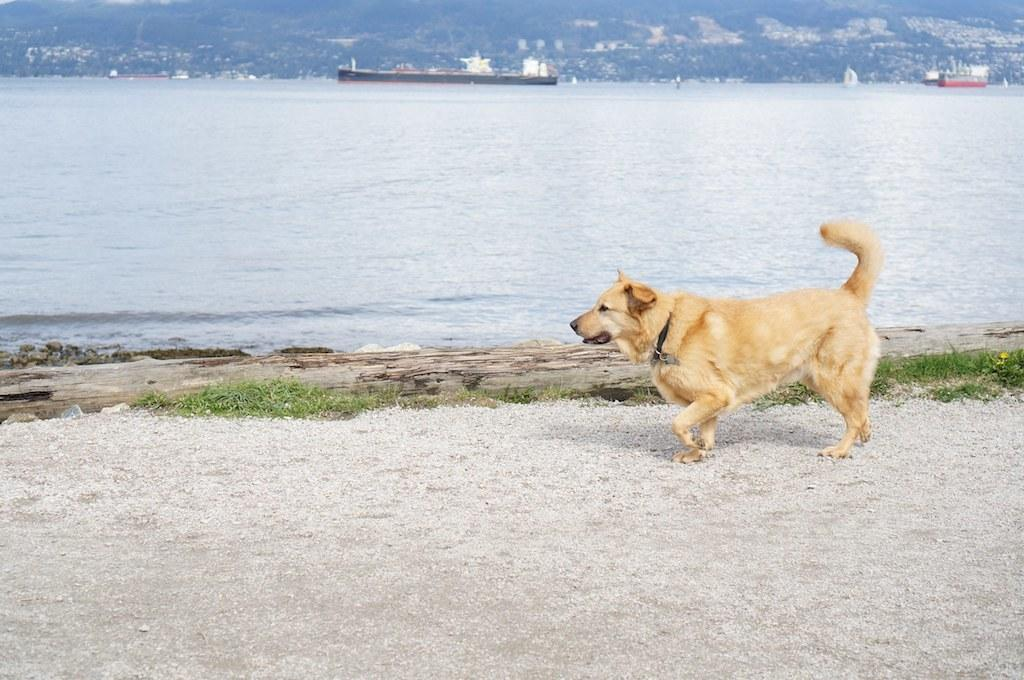What animal can be seen in the image? There is a dog in the image. What is the dog doing in the image? The dog is walking on land. What type of terrain is the dog walking on? The land has some grass. What else can be seen in the image besides the dog? There are boats sailing on the water and a hill in the background of the image. How many pizzas are being held by the girls in the image? There are no girls or pizzas present in the image. 